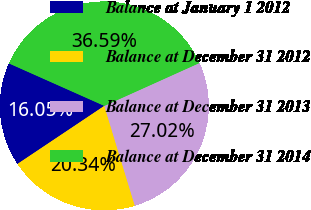Convert chart. <chart><loc_0><loc_0><loc_500><loc_500><pie_chart><fcel>Balance at January 1 2012<fcel>Balance at December 31 2012<fcel>Balance at December 31 2013<fcel>Balance at December 31 2014<nl><fcel>16.05%<fcel>20.34%<fcel>27.02%<fcel>36.59%<nl></chart> 